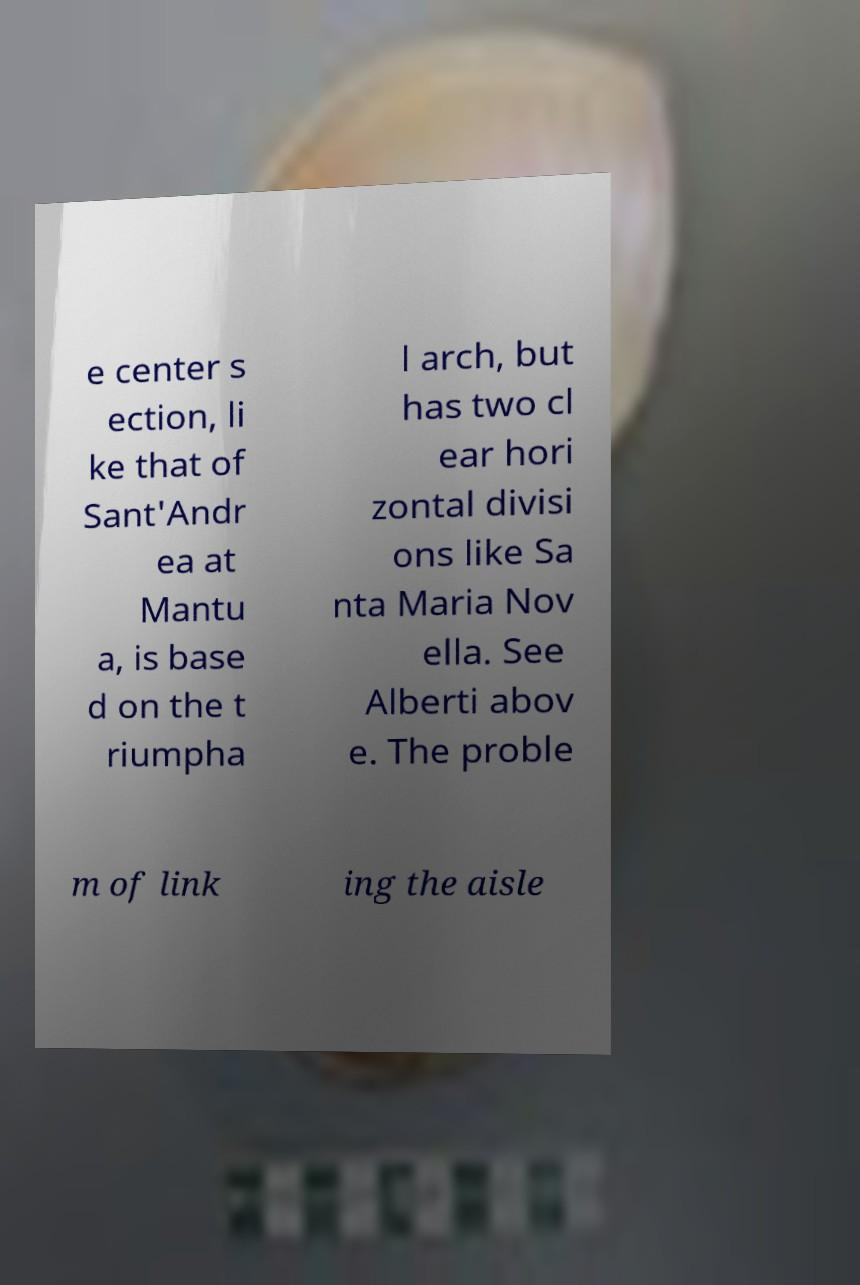For documentation purposes, I need the text within this image transcribed. Could you provide that? e center s ection, li ke that of Sant'Andr ea at Mantu a, is base d on the t riumpha l arch, but has two cl ear hori zontal divisi ons like Sa nta Maria Nov ella. See Alberti abov e. The proble m of link ing the aisle 